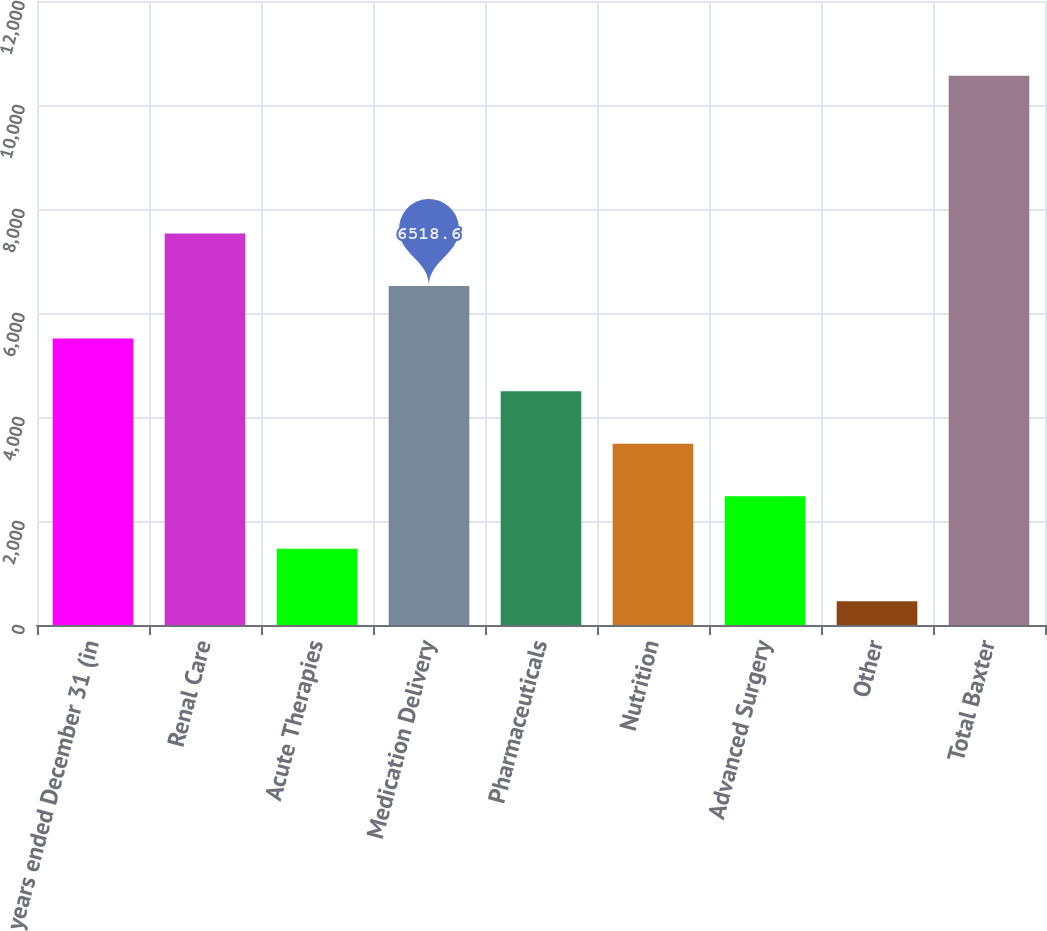Convert chart. <chart><loc_0><loc_0><loc_500><loc_500><bar_chart><fcel>years ended December 31 (in<fcel>Renal Care<fcel>Acute Therapies<fcel>Medication Delivery<fcel>Pharmaceuticals<fcel>Nutrition<fcel>Advanced Surgery<fcel>Other<fcel>Total Baxter<nl><fcel>5508<fcel>7529.2<fcel>1465.6<fcel>6518.6<fcel>4497.4<fcel>3486.8<fcel>2476.2<fcel>455<fcel>10561<nl></chart> 